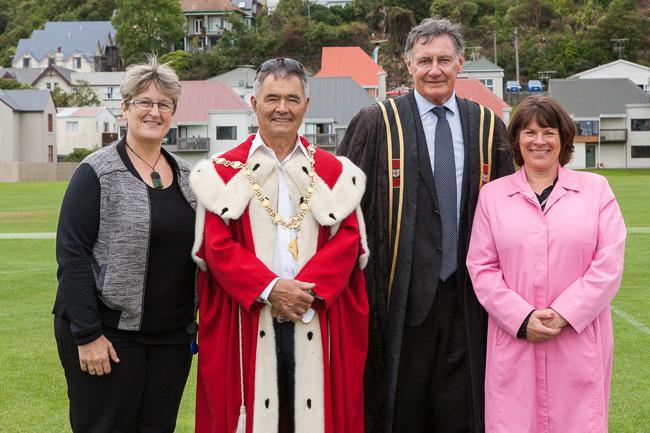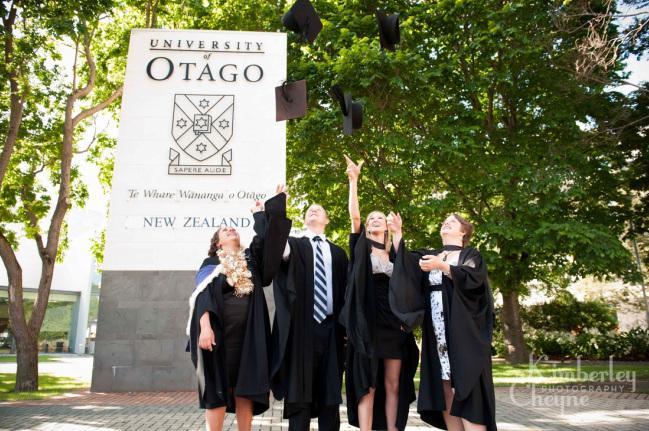The first image is the image on the left, the second image is the image on the right. For the images shown, is this caption "There is a graduate with a flower necklace." true? Answer yes or no. Yes. The first image is the image on the left, the second image is the image on the right. Analyze the images presented: Is the assertion "There are 3 people in one of the photos." valid? Answer yes or no. No. 